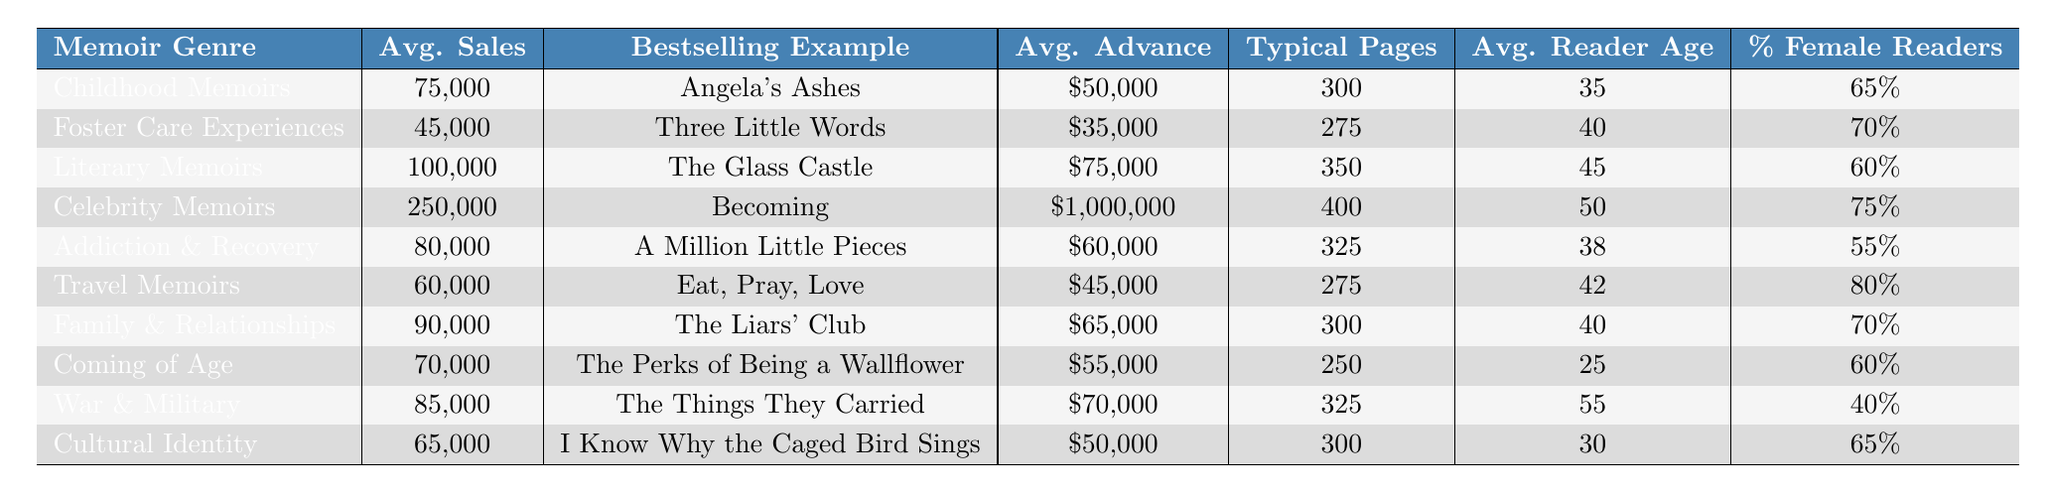What is the average sales figure for Celebrity Memoirs? According to the table, the average sales figure for Celebrity Memoirs is directly listed in the “Avg. Sales” column next to that genre, which is 250,000 units.
Answer: 250,000 Which memoir genre has the highest average advance? The table lists the average advance for all genres. Celebrity Memoirs has an average advance of 1,000,000, which is the highest among all the different genres listed.
Answer: 1,000,000 How many units do War & Military memoirs sell on average compared to Family & Relationships memoirs? War & Military memoirs have an average sales of 85,000 units, while Family & Relationships memoirs average 90,000 units. Family & Relationships sell more by 5,000 units.
Answer: Family & Relationships sell more by 5,000 units Is it true that Travel Memoirs have a larger average reader age than Coming of Age memoirs? The average reader age for Travel Memoirs is 42, and for Coming of Age, it is 25. Since 42 is greater than 25, the statement is true.
Answer: Yes What is the average sales figure for the combined genres of Addiction & Recovery and Travel Memoirs? To find the average sales for both genres, we first add their average sales (80,000 for Addiction & Recovery and 60,000 for Travel Memoirs), resulting in 140,000. Then, we divide by 2 to get the average: 140,000 / 2 = 70,000.
Answer: 70,000 Which genre has the lowest percentage of female readers, and what is that percentage? By examining the "Percentage of Female Readers" column, War & Military memoirs show the lowest percentage at 40%.
Answer: 40% What is the typical page count for Literary Memoirs, and how does it compare to the typical page count for Foster Care Experiences? Literary Memoirs have a typical page count of 350, while Foster Care Experiences have 275. Literary Memoirs have 75 more pages than Foster Care Experiences.
Answer: Literary Memoirs have 75 more pages If we consider all genres, which has the highest average sales and what is that number? Looking at the “Avg. Sales” column, Celebrity Memoirs has 250,000 units sold on average, making it the highest among all listed genres.
Answer: 250,000 How many genres listed have an average sales figure of over 80,000 units? The genres with average sales over 80,000 units are Celebrity Memoirs (250,000), Literary Memoirs (100,000), War & Military (85,000), and Addiction & Recovery (80,000). That makes 4 genres in total.
Answer: 4 What is the average reader age for Family & Relationships memoirs, and how does it compare to the average reader age for Cultural Identity memoirs? The average reader age for Family & Relationships is 40, while Cultural Identity memoirs have an average reader age of 30. Family & Relationships is older by 10 years.
Answer: Family & Relationships is older by 10 years 